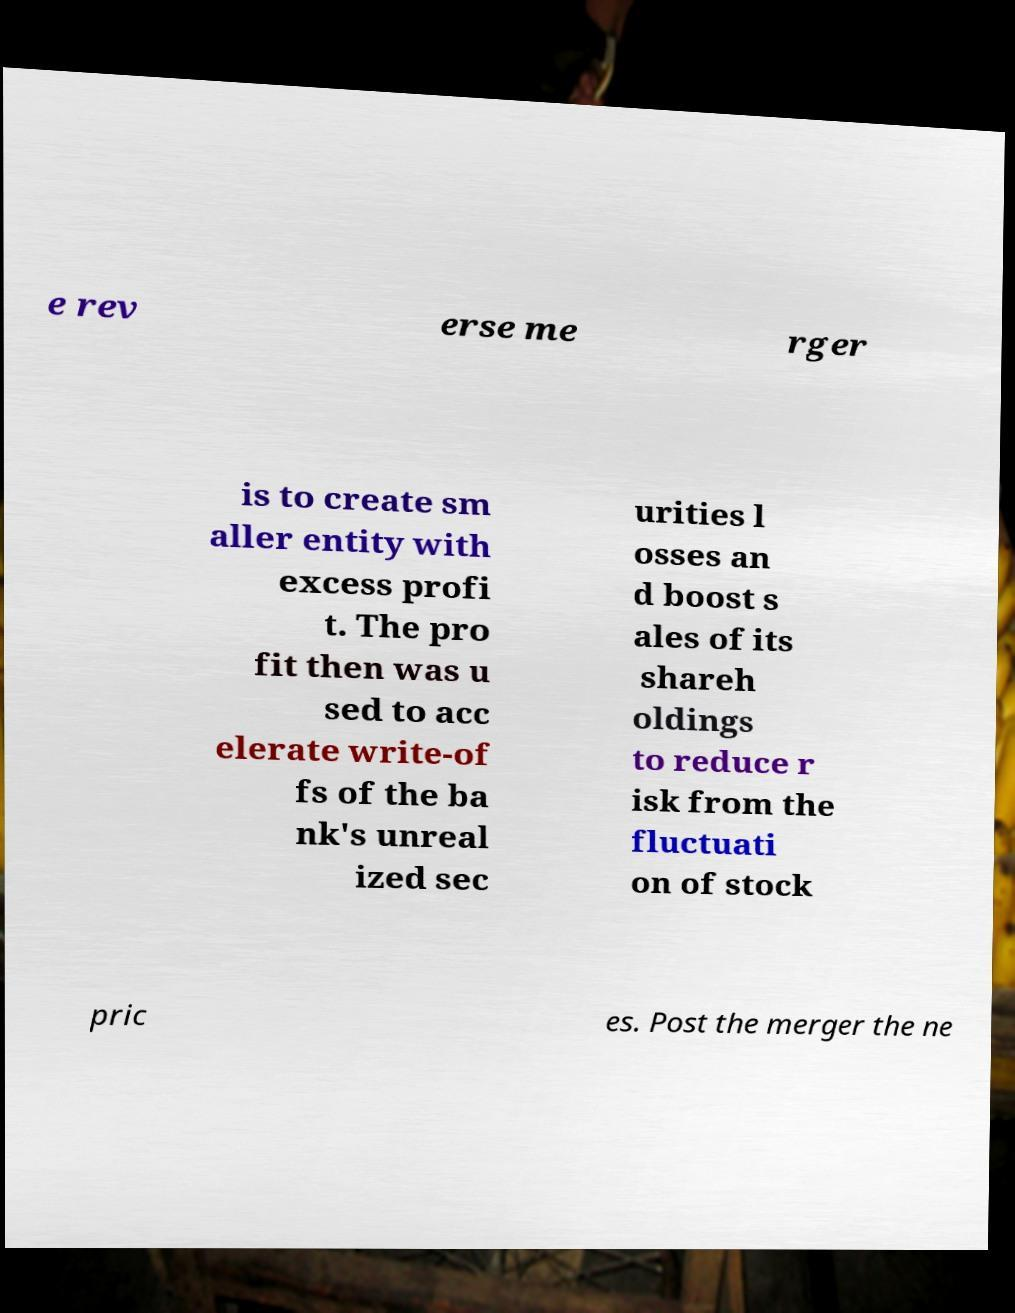Can you accurately transcribe the text from the provided image for me? e rev erse me rger is to create sm aller entity with excess profi t. The pro fit then was u sed to acc elerate write-of fs of the ba nk's unreal ized sec urities l osses an d boost s ales of its shareh oldings to reduce r isk from the fluctuati on of stock pric es. Post the merger the ne 